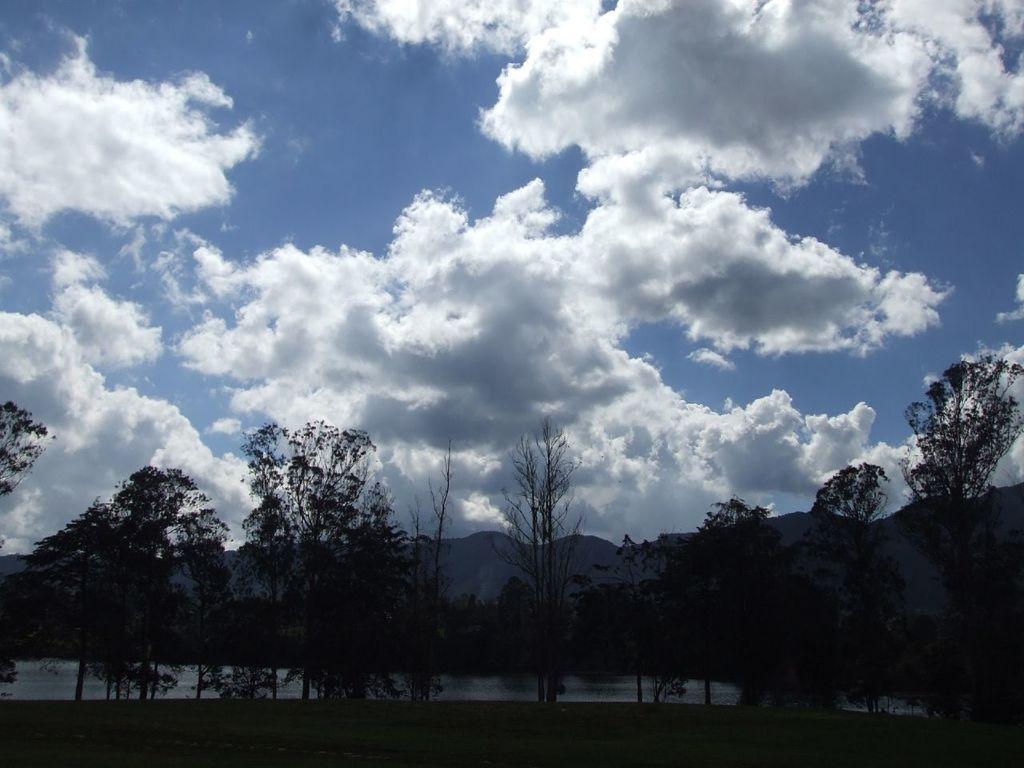How would you summarize this image in a sentence or two? In this image I can see an open grass around and number of trees in the front. In the background I can see water, mountains, clouds and the sky. 